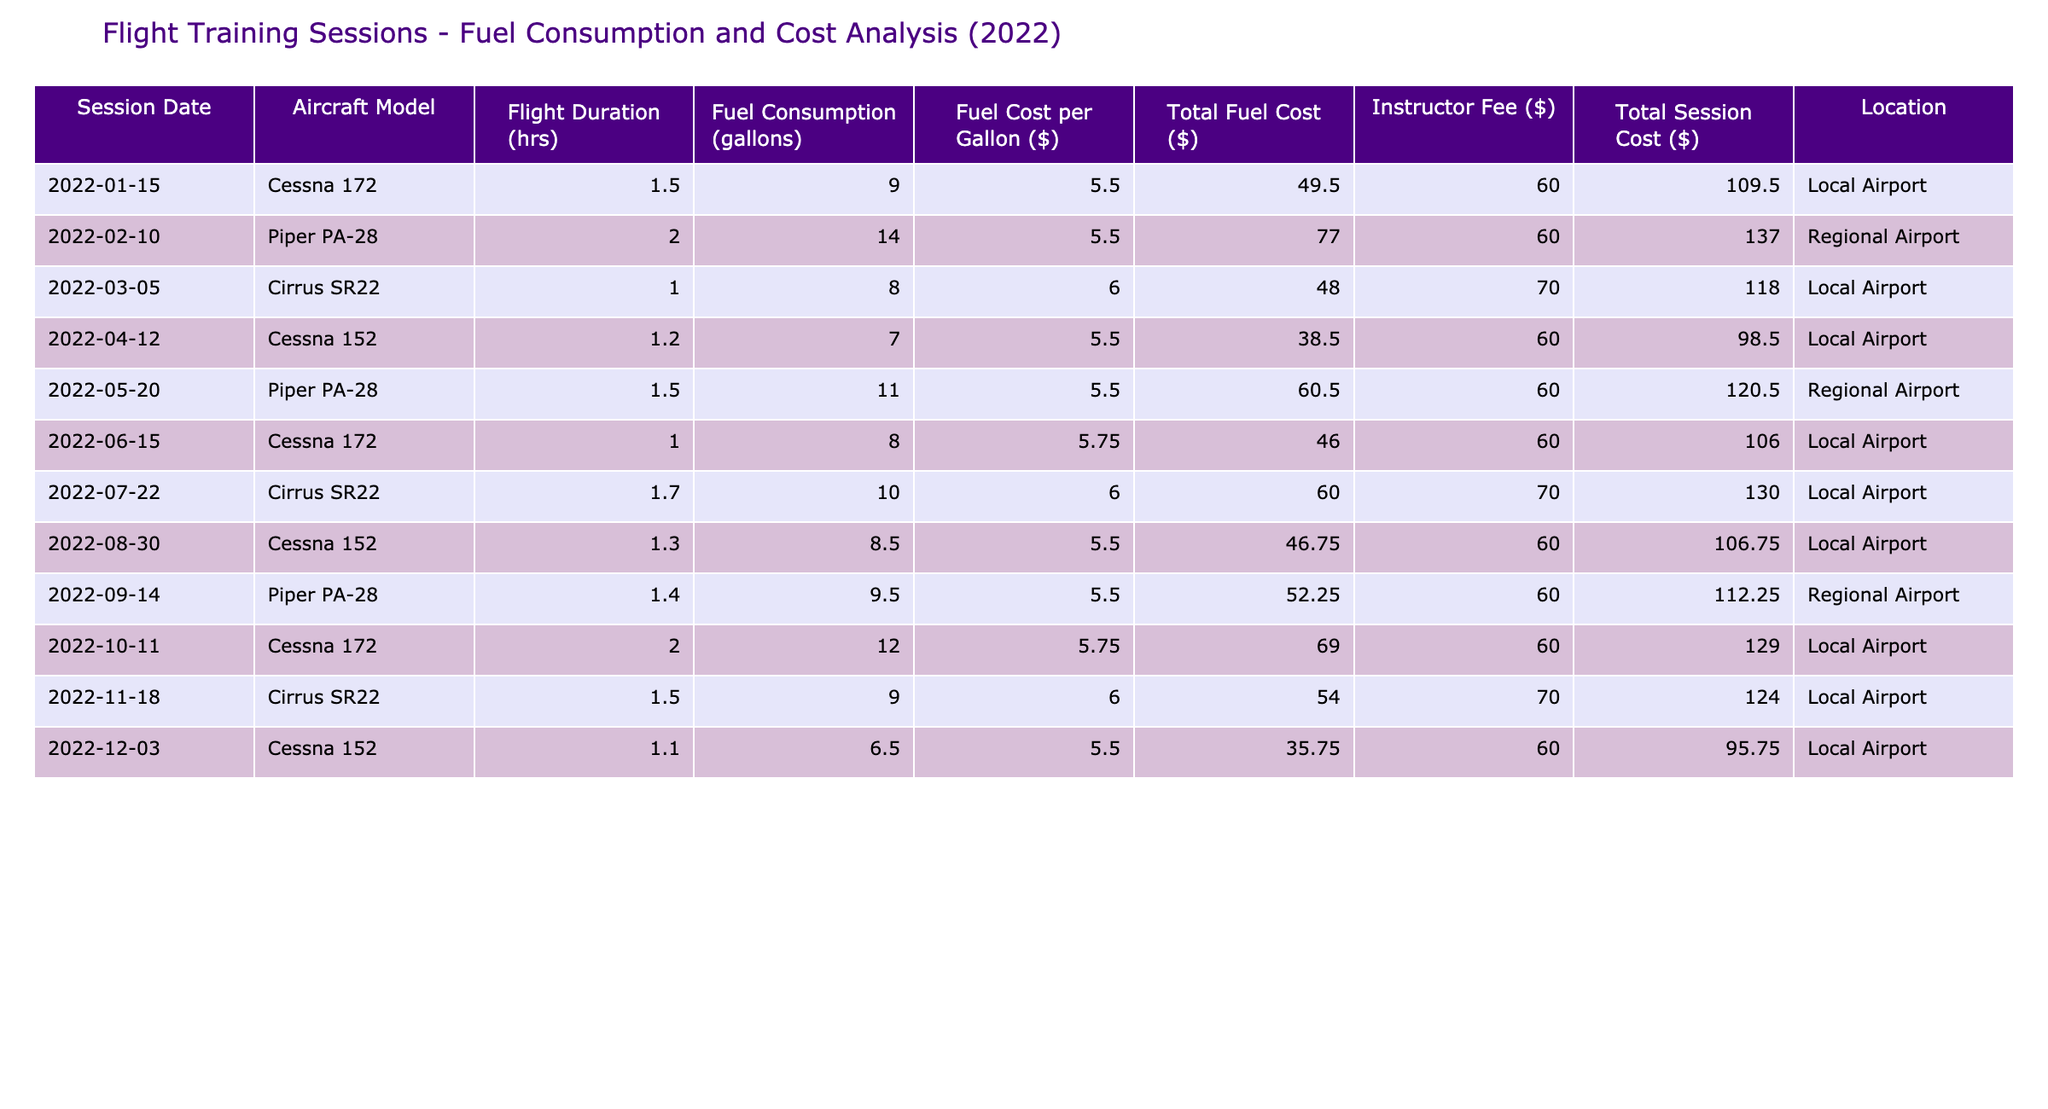What is the total fuel cost for the flight on February 10? In the table, the total fuel cost for the flight on February 10 is listed directly under "Total Fuel Cost ($)", which shows a value of 77.00.
Answer: 77.00 Which aircraft model had the highest fuel consumption in a single session? By reviewing the "Fuel Consumption (gallons)" column, the highest value is 14 gallons, which corresponds to the Piper PA-28 flight on February 10.
Answer: Piper PA-28 What is the average total session cost across all flights? To find the average, sum all the "Total Session Cost ($)" values and divide by the total number of sessions (which is 12). The total cost sums up to 1,425.50; dividing by 12 gives 118.79.
Answer: 118.79 Was the total session cost for the flight on November 18 higher than that for the flight on March 5? The total session cost on November 18 is 124.00 and on March 5, it is 118.00. Since 124.00 is greater than 118.00, the statement is true.
Answer: Yes Which session has the lowest total fuel cost and what is that cost? By examining the "Total Fuel Cost ($)" column, the lowest cost is found on December 3 with a value of 35.75.
Answer: 35.75 How much more did the session on October 11 cost compared to the session on April 12? The total session cost on October 11 is 129.00 and on April 12 it is 98.50. The difference is 129.00 - 98.50 = 30.50.
Answer: 30.50 Did the Cessna 152 model have any sessions that exceeded a fuel consumption of 7 gallons? The Cessna 152 flights occurred on April 12 and December 3, with fuel consumptions of 7 gallons (April) and 6.5 gallons (December). Neither exceeded 7 gallons, so the answer is no.
Answer: No What was the total flight hours consumed by Piper PA-28 throughout 2022? The Piper PA-28 was flown in three sessions with durations of 2.0, 1.5, and 1.4 hours. Adding these gives 2.0 + 1.5 + 1.4 = 4.9 hours.
Answer: 4.9 hours Which session location had the most total session costs on average? The local airport has sessions totaling 109.50, 48.00, 98.50, 106.00, 130.00, 124.00, and 95.75, which yields an average of 109.86, while the regional airport has costs of 137.00, 120.50, and 112.25, averaging 123.58. Therefore, the local airport had a lower average session cost.
Answer: Local Airport Which session had the highest instructor fee? Reviewing the "Instructor Fee ($)" column, the highest fee is 70, which corresponds to the Cirrus SR22 flights on March 5 and November 18.
Answer: 70 